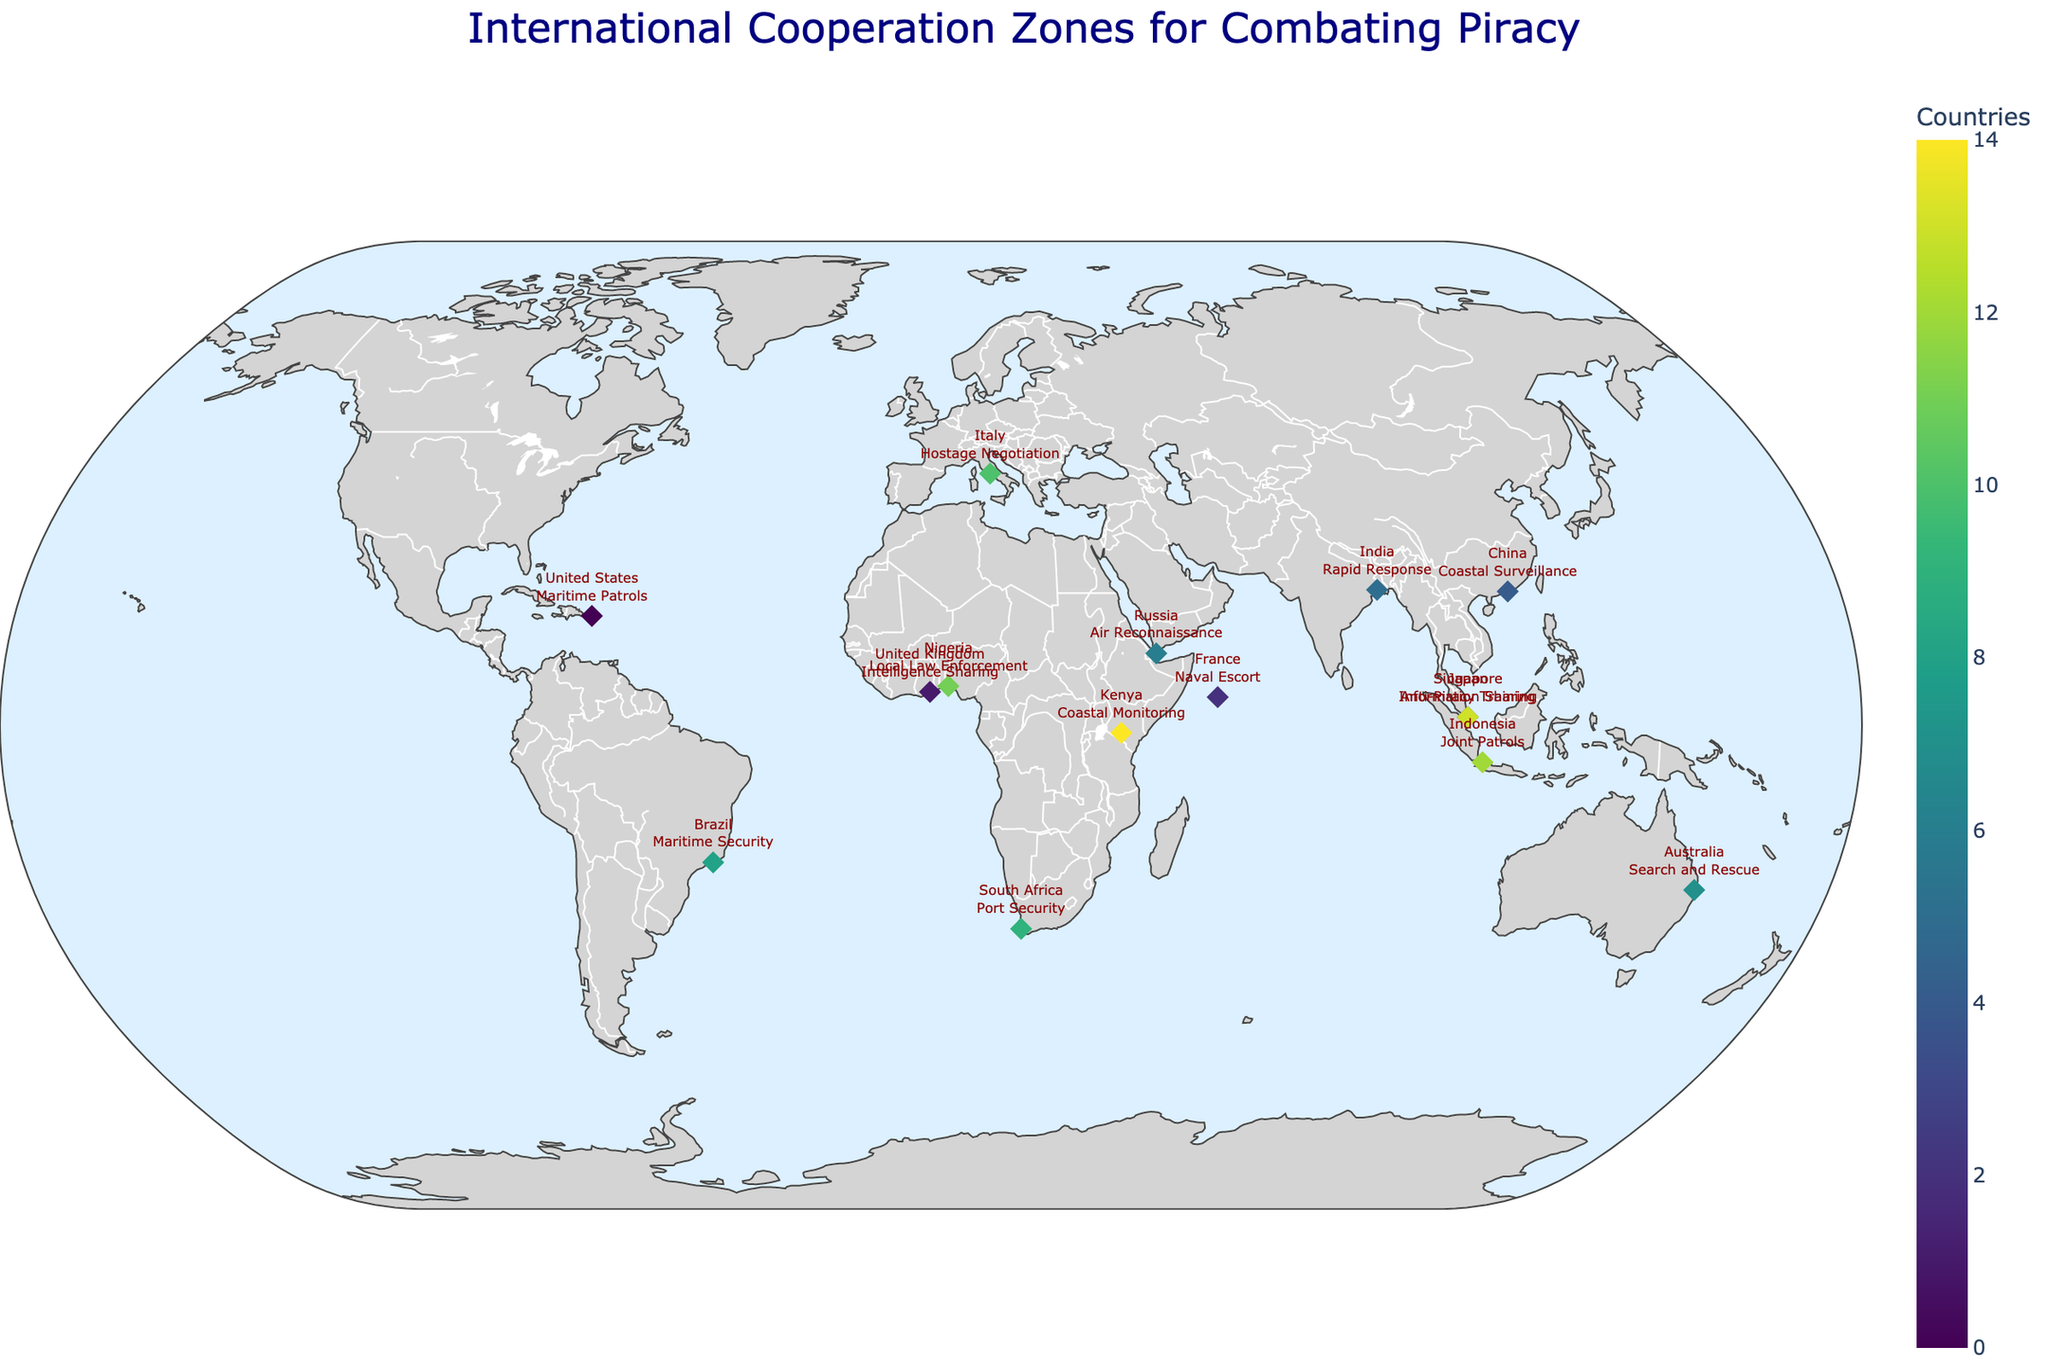What is the title of the map? The title is found at the top center of the map in a large, navy-colored font.
Answer: International Cooperation Zones for Combating Piracy Which country's responsibility is in the Indian Ocean region? By examining the location markers and labels, the country outlined in the Indian Ocean region (coordinates near 4.6796, 55.4920) is France.
Answer: France How many countries are shown participating in anti-piracy efforts? Count the number of unique markers for each country on the map.
Answer: 15 Which region involves the country responsible for rapid response? Identify the country assigned to "Rapid Response" and then look for the corresponding region in the data. The country listed for rapid response is India, and its assigned region is the Bay of Bengal.
Answer: Bay of Bengal Compare the responsibilities of the United Kingdom and Nigeria. Locate the markers for the United Kingdom and Nigeria and read their associated responsibilities.
Answer: The United Kingdom is responsible for Intelligence Sharing, and Nigeria is responsible for Local Law Enforcement Which country is positioned near the coordinates 41.9028, 12.4964? Find the corresponding marker on the map that is closest to the provided latitude and longitude.
Answer: Italy What type of operations does Japan focus on in its designated region? Locate Japan on the map and refer to the textual information provided.
Answer: Anti-Piracy Training How many countries have responsibilities in the Gulf of Guinea? Count the number of countries labeled within the Gulf of Guinea region.
Answer: 2 Which regions have countries that provide port security as part of their anti-piracy efforts? Identify the regions associated with responsibilities involving port security. South Africa handles port security in the Mozambique Channel.
Answer: Mozambique Channel Is there any region where more than one country shares responsibility? Look for regions on the map that have markers from multiple countries. The Gulf of Guinea has both the United Kingdom and Nigeria sharing responsibilities.
Answer: Yes 